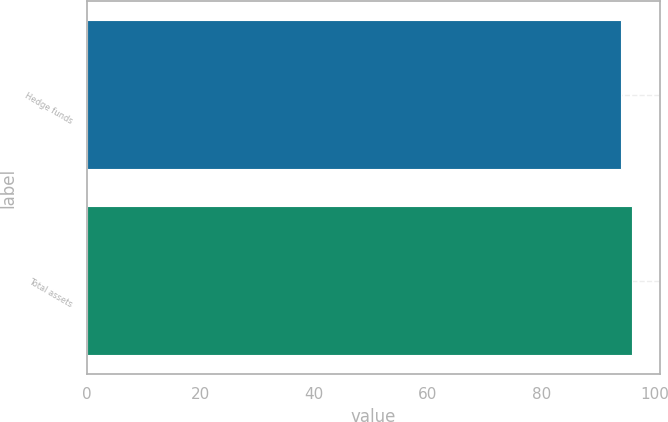Convert chart to OTSL. <chart><loc_0><loc_0><loc_500><loc_500><bar_chart><fcel>Hedge funds<fcel>Total assets<nl><fcel>94<fcel>96<nl></chart> 